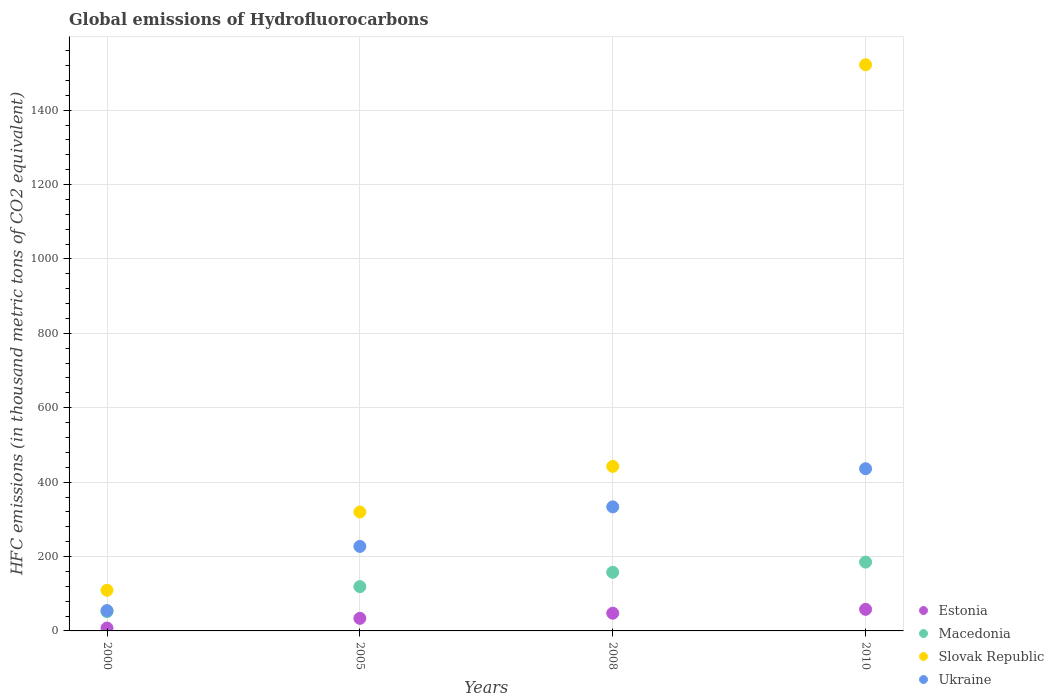What is the global emissions of Hydrofluorocarbons in Macedonia in 2010?
Offer a terse response. 185. Across all years, what is the maximum global emissions of Hydrofluorocarbons in Estonia?
Your response must be concise. 58. Across all years, what is the minimum global emissions of Hydrofluorocarbons in Slovak Republic?
Provide a short and direct response. 109.3. In which year was the global emissions of Hydrofluorocarbons in Ukraine maximum?
Ensure brevity in your answer.  2010. In which year was the global emissions of Hydrofluorocarbons in Slovak Republic minimum?
Provide a succinct answer. 2000. What is the total global emissions of Hydrofluorocarbons in Ukraine in the graph?
Your answer should be very brief. 1051.4. What is the difference between the global emissions of Hydrofluorocarbons in Macedonia in 2000 and that in 2010?
Your answer should be very brief. -133.2. What is the difference between the global emissions of Hydrofluorocarbons in Estonia in 2005 and the global emissions of Hydrofluorocarbons in Slovak Republic in 2010?
Keep it short and to the point. -1488.2. What is the average global emissions of Hydrofluorocarbons in Slovak Republic per year?
Your answer should be very brief. 598.33. In the year 2010, what is the difference between the global emissions of Hydrofluorocarbons in Estonia and global emissions of Hydrofluorocarbons in Slovak Republic?
Offer a terse response. -1464. What is the ratio of the global emissions of Hydrofluorocarbons in Ukraine in 2000 to that in 2005?
Give a very brief answer. 0.24. Is the difference between the global emissions of Hydrofluorocarbons in Estonia in 2000 and 2005 greater than the difference between the global emissions of Hydrofluorocarbons in Slovak Republic in 2000 and 2005?
Your answer should be compact. Yes. What is the difference between the highest and the second highest global emissions of Hydrofluorocarbons in Slovak Republic?
Give a very brief answer. 1079.7. What is the difference between the highest and the lowest global emissions of Hydrofluorocarbons in Macedonia?
Keep it short and to the point. 133.2. Is the sum of the global emissions of Hydrofluorocarbons in Macedonia in 2000 and 2008 greater than the maximum global emissions of Hydrofluorocarbons in Slovak Republic across all years?
Keep it short and to the point. No. Is it the case that in every year, the sum of the global emissions of Hydrofluorocarbons in Macedonia and global emissions of Hydrofluorocarbons in Estonia  is greater than the sum of global emissions of Hydrofluorocarbons in Slovak Republic and global emissions of Hydrofluorocarbons in Ukraine?
Ensure brevity in your answer.  No. Is it the case that in every year, the sum of the global emissions of Hydrofluorocarbons in Slovak Republic and global emissions of Hydrofluorocarbons in Macedonia  is greater than the global emissions of Hydrofluorocarbons in Estonia?
Provide a succinct answer. Yes. Is the global emissions of Hydrofluorocarbons in Slovak Republic strictly greater than the global emissions of Hydrofluorocarbons in Estonia over the years?
Provide a succinct answer. Yes. Is the global emissions of Hydrofluorocarbons in Slovak Republic strictly less than the global emissions of Hydrofluorocarbons in Estonia over the years?
Provide a succinct answer. No. How many years are there in the graph?
Keep it short and to the point. 4. Does the graph contain any zero values?
Your response must be concise. No. Does the graph contain grids?
Your answer should be compact. Yes. Where does the legend appear in the graph?
Make the answer very short. Bottom right. What is the title of the graph?
Provide a succinct answer. Global emissions of Hydrofluorocarbons. Does "Congo (Republic)" appear as one of the legend labels in the graph?
Provide a short and direct response. No. What is the label or title of the Y-axis?
Make the answer very short. HFC emissions (in thousand metric tons of CO2 equivalent). What is the HFC emissions (in thousand metric tons of CO2 equivalent) of Estonia in 2000?
Your answer should be very brief. 7.8. What is the HFC emissions (in thousand metric tons of CO2 equivalent) in Macedonia in 2000?
Offer a very short reply. 51.8. What is the HFC emissions (in thousand metric tons of CO2 equivalent) in Slovak Republic in 2000?
Your answer should be very brief. 109.3. What is the HFC emissions (in thousand metric tons of CO2 equivalent) of Ukraine in 2000?
Provide a short and direct response. 54.7. What is the HFC emissions (in thousand metric tons of CO2 equivalent) of Estonia in 2005?
Your response must be concise. 33.8. What is the HFC emissions (in thousand metric tons of CO2 equivalent) in Macedonia in 2005?
Offer a terse response. 119.1. What is the HFC emissions (in thousand metric tons of CO2 equivalent) in Slovak Republic in 2005?
Offer a terse response. 319.7. What is the HFC emissions (in thousand metric tons of CO2 equivalent) of Ukraine in 2005?
Your answer should be very brief. 227.2. What is the HFC emissions (in thousand metric tons of CO2 equivalent) in Estonia in 2008?
Your response must be concise. 47.6. What is the HFC emissions (in thousand metric tons of CO2 equivalent) in Macedonia in 2008?
Your response must be concise. 157.6. What is the HFC emissions (in thousand metric tons of CO2 equivalent) of Slovak Republic in 2008?
Offer a very short reply. 442.3. What is the HFC emissions (in thousand metric tons of CO2 equivalent) of Ukraine in 2008?
Offer a very short reply. 333.5. What is the HFC emissions (in thousand metric tons of CO2 equivalent) of Estonia in 2010?
Provide a succinct answer. 58. What is the HFC emissions (in thousand metric tons of CO2 equivalent) in Macedonia in 2010?
Offer a terse response. 185. What is the HFC emissions (in thousand metric tons of CO2 equivalent) of Slovak Republic in 2010?
Offer a terse response. 1522. What is the HFC emissions (in thousand metric tons of CO2 equivalent) of Ukraine in 2010?
Offer a terse response. 436. Across all years, what is the maximum HFC emissions (in thousand metric tons of CO2 equivalent) in Macedonia?
Make the answer very short. 185. Across all years, what is the maximum HFC emissions (in thousand metric tons of CO2 equivalent) in Slovak Republic?
Ensure brevity in your answer.  1522. Across all years, what is the maximum HFC emissions (in thousand metric tons of CO2 equivalent) in Ukraine?
Offer a very short reply. 436. Across all years, what is the minimum HFC emissions (in thousand metric tons of CO2 equivalent) of Estonia?
Keep it short and to the point. 7.8. Across all years, what is the minimum HFC emissions (in thousand metric tons of CO2 equivalent) of Macedonia?
Your response must be concise. 51.8. Across all years, what is the minimum HFC emissions (in thousand metric tons of CO2 equivalent) of Slovak Republic?
Offer a very short reply. 109.3. Across all years, what is the minimum HFC emissions (in thousand metric tons of CO2 equivalent) in Ukraine?
Ensure brevity in your answer.  54.7. What is the total HFC emissions (in thousand metric tons of CO2 equivalent) of Estonia in the graph?
Offer a very short reply. 147.2. What is the total HFC emissions (in thousand metric tons of CO2 equivalent) in Macedonia in the graph?
Ensure brevity in your answer.  513.5. What is the total HFC emissions (in thousand metric tons of CO2 equivalent) in Slovak Republic in the graph?
Offer a terse response. 2393.3. What is the total HFC emissions (in thousand metric tons of CO2 equivalent) of Ukraine in the graph?
Your response must be concise. 1051.4. What is the difference between the HFC emissions (in thousand metric tons of CO2 equivalent) in Macedonia in 2000 and that in 2005?
Provide a short and direct response. -67.3. What is the difference between the HFC emissions (in thousand metric tons of CO2 equivalent) of Slovak Republic in 2000 and that in 2005?
Provide a short and direct response. -210.4. What is the difference between the HFC emissions (in thousand metric tons of CO2 equivalent) in Ukraine in 2000 and that in 2005?
Keep it short and to the point. -172.5. What is the difference between the HFC emissions (in thousand metric tons of CO2 equivalent) in Estonia in 2000 and that in 2008?
Offer a very short reply. -39.8. What is the difference between the HFC emissions (in thousand metric tons of CO2 equivalent) in Macedonia in 2000 and that in 2008?
Your answer should be compact. -105.8. What is the difference between the HFC emissions (in thousand metric tons of CO2 equivalent) of Slovak Republic in 2000 and that in 2008?
Offer a terse response. -333. What is the difference between the HFC emissions (in thousand metric tons of CO2 equivalent) in Ukraine in 2000 and that in 2008?
Your response must be concise. -278.8. What is the difference between the HFC emissions (in thousand metric tons of CO2 equivalent) of Estonia in 2000 and that in 2010?
Make the answer very short. -50.2. What is the difference between the HFC emissions (in thousand metric tons of CO2 equivalent) of Macedonia in 2000 and that in 2010?
Your answer should be very brief. -133.2. What is the difference between the HFC emissions (in thousand metric tons of CO2 equivalent) in Slovak Republic in 2000 and that in 2010?
Offer a terse response. -1412.7. What is the difference between the HFC emissions (in thousand metric tons of CO2 equivalent) in Ukraine in 2000 and that in 2010?
Make the answer very short. -381.3. What is the difference between the HFC emissions (in thousand metric tons of CO2 equivalent) in Estonia in 2005 and that in 2008?
Your response must be concise. -13.8. What is the difference between the HFC emissions (in thousand metric tons of CO2 equivalent) in Macedonia in 2005 and that in 2008?
Offer a very short reply. -38.5. What is the difference between the HFC emissions (in thousand metric tons of CO2 equivalent) in Slovak Republic in 2005 and that in 2008?
Keep it short and to the point. -122.6. What is the difference between the HFC emissions (in thousand metric tons of CO2 equivalent) in Ukraine in 2005 and that in 2008?
Your answer should be compact. -106.3. What is the difference between the HFC emissions (in thousand metric tons of CO2 equivalent) of Estonia in 2005 and that in 2010?
Ensure brevity in your answer.  -24.2. What is the difference between the HFC emissions (in thousand metric tons of CO2 equivalent) of Macedonia in 2005 and that in 2010?
Your answer should be compact. -65.9. What is the difference between the HFC emissions (in thousand metric tons of CO2 equivalent) of Slovak Republic in 2005 and that in 2010?
Your answer should be very brief. -1202.3. What is the difference between the HFC emissions (in thousand metric tons of CO2 equivalent) of Ukraine in 2005 and that in 2010?
Provide a succinct answer. -208.8. What is the difference between the HFC emissions (in thousand metric tons of CO2 equivalent) in Estonia in 2008 and that in 2010?
Offer a terse response. -10.4. What is the difference between the HFC emissions (in thousand metric tons of CO2 equivalent) in Macedonia in 2008 and that in 2010?
Keep it short and to the point. -27.4. What is the difference between the HFC emissions (in thousand metric tons of CO2 equivalent) of Slovak Republic in 2008 and that in 2010?
Your answer should be compact. -1079.7. What is the difference between the HFC emissions (in thousand metric tons of CO2 equivalent) in Ukraine in 2008 and that in 2010?
Offer a terse response. -102.5. What is the difference between the HFC emissions (in thousand metric tons of CO2 equivalent) in Estonia in 2000 and the HFC emissions (in thousand metric tons of CO2 equivalent) in Macedonia in 2005?
Give a very brief answer. -111.3. What is the difference between the HFC emissions (in thousand metric tons of CO2 equivalent) of Estonia in 2000 and the HFC emissions (in thousand metric tons of CO2 equivalent) of Slovak Republic in 2005?
Offer a terse response. -311.9. What is the difference between the HFC emissions (in thousand metric tons of CO2 equivalent) of Estonia in 2000 and the HFC emissions (in thousand metric tons of CO2 equivalent) of Ukraine in 2005?
Your answer should be very brief. -219.4. What is the difference between the HFC emissions (in thousand metric tons of CO2 equivalent) in Macedonia in 2000 and the HFC emissions (in thousand metric tons of CO2 equivalent) in Slovak Republic in 2005?
Ensure brevity in your answer.  -267.9. What is the difference between the HFC emissions (in thousand metric tons of CO2 equivalent) of Macedonia in 2000 and the HFC emissions (in thousand metric tons of CO2 equivalent) of Ukraine in 2005?
Provide a short and direct response. -175.4. What is the difference between the HFC emissions (in thousand metric tons of CO2 equivalent) of Slovak Republic in 2000 and the HFC emissions (in thousand metric tons of CO2 equivalent) of Ukraine in 2005?
Your answer should be compact. -117.9. What is the difference between the HFC emissions (in thousand metric tons of CO2 equivalent) in Estonia in 2000 and the HFC emissions (in thousand metric tons of CO2 equivalent) in Macedonia in 2008?
Offer a very short reply. -149.8. What is the difference between the HFC emissions (in thousand metric tons of CO2 equivalent) of Estonia in 2000 and the HFC emissions (in thousand metric tons of CO2 equivalent) of Slovak Republic in 2008?
Provide a succinct answer. -434.5. What is the difference between the HFC emissions (in thousand metric tons of CO2 equivalent) of Estonia in 2000 and the HFC emissions (in thousand metric tons of CO2 equivalent) of Ukraine in 2008?
Keep it short and to the point. -325.7. What is the difference between the HFC emissions (in thousand metric tons of CO2 equivalent) in Macedonia in 2000 and the HFC emissions (in thousand metric tons of CO2 equivalent) in Slovak Republic in 2008?
Provide a succinct answer. -390.5. What is the difference between the HFC emissions (in thousand metric tons of CO2 equivalent) of Macedonia in 2000 and the HFC emissions (in thousand metric tons of CO2 equivalent) of Ukraine in 2008?
Give a very brief answer. -281.7. What is the difference between the HFC emissions (in thousand metric tons of CO2 equivalent) of Slovak Republic in 2000 and the HFC emissions (in thousand metric tons of CO2 equivalent) of Ukraine in 2008?
Provide a succinct answer. -224.2. What is the difference between the HFC emissions (in thousand metric tons of CO2 equivalent) in Estonia in 2000 and the HFC emissions (in thousand metric tons of CO2 equivalent) in Macedonia in 2010?
Your answer should be very brief. -177.2. What is the difference between the HFC emissions (in thousand metric tons of CO2 equivalent) of Estonia in 2000 and the HFC emissions (in thousand metric tons of CO2 equivalent) of Slovak Republic in 2010?
Your answer should be compact. -1514.2. What is the difference between the HFC emissions (in thousand metric tons of CO2 equivalent) of Estonia in 2000 and the HFC emissions (in thousand metric tons of CO2 equivalent) of Ukraine in 2010?
Your answer should be very brief. -428.2. What is the difference between the HFC emissions (in thousand metric tons of CO2 equivalent) in Macedonia in 2000 and the HFC emissions (in thousand metric tons of CO2 equivalent) in Slovak Republic in 2010?
Make the answer very short. -1470.2. What is the difference between the HFC emissions (in thousand metric tons of CO2 equivalent) of Macedonia in 2000 and the HFC emissions (in thousand metric tons of CO2 equivalent) of Ukraine in 2010?
Ensure brevity in your answer.  -384.2. What is the difference between the HFC emissions (in thousand metric tons of CO2 equivalent) of Slovak Republic in 2000 and the HFC emissions (in thousand metric tons of CO2 equivalent) of Ukraine in 2010?
Make the answer very short. -326.7. What is the difference between the HFC emissions (in thousand metric tons of CO2 equivalent) in Estonia in 2005 and the HFC emissions (in thousand metric tons of CO2 equivalent) in Macedonia in 2008?
Make the answer very short. -123.8. What is the difference between the HFC emissions (in thousand metric tons of CO2 equivalent) in Estonia in 2005 and the HFC emissions (in thousand metric tons of CO2 equivalent) in Slovak Republic in 2008?
Provide a short and direct response. -408.5. What is the difference between the HFC emissions (in thousand metric tons of CO2 equivalent) of Estonia in 2005 and the HFC emissions (in thousand metric tons of CO2 equivalent) of Ukraine in 2008?
Give a very brief answer. -299.7. What is the difference between the HFC emissions (in thousand metric tons of CO2 equivalent) of Macedonia in 2005 and the HFC emissions (in thousand metric tons of CO2 equivalent) of Slovak Republic in 2008?
Offer a very short reply. -323.2. What is the difference between the HFC emissions (in thousand metric tons of CO2 equivalent) in Macedonia in 2005 and the HFC emissions (in thousand metric tons of CO2 equivalent) in Ukraine in 2008?
Your answer should be very brief. -214.4. What is the difference between the HFC emissions (in thousand metric tons of CO2 equivalent) in Slovak Republic in 2005 and the HFC emissions (in thousand metric tons of CO2 equivalent) in Ukraine in 2008?
Ensure brevity in your answer.  -13.8. What is the difference between the HFC emissions (in thousand metric tons of CO2 equivalent) in Estonia in 2005 and the HFC emissions (in thousand metric tons of CO2 equivalent) in Macedonia in 2010?
Your response must be concise. -151.2. What is the difference between the HFC emissions (in thousand metric tons of CO2 equivalent) of Estonia in 2005 and the HFC emissions (in thousand metric tons of CO2 equivalent) of Slovak Republic in 2010?
Provide a short and direct response. -1488.2. What is the difference between the HFC emissions (in thousand metric tons of CO2 equivalent) of Estonia in 2005 and the HFC emissions (in thousand metric tons of CO2 equivalent) of Ukraine in 2010?
Make the answer very short. -402.2. What is the difference between the HFC emissions (in thousand metric tons of CO2 equivalent) of Macedonia in 2005 and the HFC emissions (in thousand metric tons of CO2 equivalent) of Slovak Republic in 2010?
Ensure brevity in your answer.  -1402.9. What is the difference between the HFC emissions (in thousand metric tons of CO2 equivalent) in Macedonia in 2005 and the HFC emissions (in thousand metric tons of CO2 equivalent) in Ukraine in 2010?
Your response must be concise. -316.9. What is the difference between the HFC emissions (in thousand metric tons of CO2 equivalent) of Slovak Republic in 2005 and the HFC emissions (in thousand metric tons of CO2 equivalent) of Ukraine in 2010?
Your response must be concise. -116.3. What is the difference between the HFC emissions (in thousand metric tons of CO2 equivalent) in Estonia in 2008 and the HFC emissions (in thousand metric tons of CO2 equivalent) in Macedonia in 2010?
Keep it short and to the point. -137.4. What is the difference between the HFC emissions (in thousand metric tons of CO2 equivalent) of Estonia in 2008 and the HFC emissions (in thousand metric tons of CO2 equivalent) of Slovak Republic in 2010?
Ensure brevity in your answer.  -1474.4. What is the difference between the HFC emissions (in thousand metric tons of CO2 equivalent) in Estonia in 2008 and the HFC emissions (in thousand metric tons of CO2 equivalent) in Ukraine in 2010?
Your answer should be very brief. -388.4. What is the difference between the HFC emissions (in thousand metric tons of CO2 equivalent) in Macedonia in 2008 and the HFC emissions (in thousand metric tons of CO2 equivalent) in Slovak Republic in 2010?
Ensure brevity in your answer.  -1364.4. What is the difference between the HFC emissions (in thousand metric tons of CO2 equivalent) in Macedonia in 2008 and the HFC emissions (in thousand metric tons of CO2 equivalent) in Ukraine in 2010?
Ensure brevity in your answer.  -278.4. What is the average HFC emissions (in thousand metric tons of CO2 equivalent) in Estonia per year?
Provide a short and direct response. 36.8. What is the average HFC emissions (in thousand metric tons of CO2 equivalent) in Macedonia per year?
Offer a terse response. 128.38. What is the average HFC emissions (in thousand metric tons of CO2 equivalent) of Slovak Republic per year?
Offer a very short reply. 598.33. What is the average HFC emissions (in thousand metric tons of CO2 equivalent) in Ukraine per year?
Give a very brief answer. 262.85. In the year 2000, what is the difference between the HFC emissions (in thousand metric tons of CO2 equivalent) of Estonia and HFC emissions (in thousand metric tons of CO2 equivalent) of Macedonia?
Make the answer very short. -44. In the year 2000, what is the difference between the HFC emissions (in thousand metric tons of CO2 equivalent) in Estonia and HFC emissions (in thousand metric tons of CO2 equivalent) in Slovak Republic?
Your answer should be compact. -101.5. In the year 2000, what is the difference between the HFC emissions (in thousand metric tons of CO2 equivalent) of Estonia and HFC emissions (in thousand metric tons of CO2 equivalent) of Ukraine?
Ensure brevity in your answer.  -46.9. In the year 2000, what is the difference between the HFC emissions (in thousand metric tons of CO2 equivalent) of Macedonia and HFC emissions (in thousand metric tons of CO2 equivalent) of Slovak Republic?
Your response must be concise. -57.5. In the year 2000, what is the difference between the HFC emissions (in thousand metric tons of CO2 equivalent) of Slovak Republic and HFC emissions (in thousand metric tons of CO2 equivalent) of Ukraine?
Provide a succinct answer. 54.6. In the year 2005, what is the difference between the HFC emissions (in thousand metric tons of CO2 equivalent) in Estonia and HFC emissions (in thousand metric tons of CO2 equivalent) in Macedonia?
Your answer should be very brief. -85.3. In the year 2005, what is the difference between the HFC emissions (in thousand metric tons of CO2 equivalent) in Estonia and HFC emissions (in thousand metric tons of CO2 equivalent) in Slovak Republic?
Ensure brevity in your answer.  -285.9. In the year 2005, what is the difference between the HFC emissions (in thousand metric tons of CO2 equivalent) of Estonia and HFC emissions (in thousand metric tons of CO2 equivalent) of Ukraine?
Ensure brevity in your answer.  -193.4. In the year 2005, what is the difference between the HFC emissions (in thousand metric tons of CO2 equivalent) of Macedonia and HFC emissions (in thousand metric tons of CO2 equivalent) of Slovak Republic?
Give a very brief answer. -200.6. In the year 2005, what is the difference between the HFC emissions (in thousand metric tons of CO2 equivalent) in Macedonia and HFC emissions (in thousand metric tons of CO2 equivalent) in Ukraine?
Offer a very short reply. -108.1. In the year 2005, what is the difference between the HFC emissions (in thousand metric tons of CO2 equivalent) of Slovak Republic and HFC emissions (in thousand metric tons of CO2 equivalent) of Ukraine?
Your answer should be very brief. 92.5. In the year 2008, what is the difference between the HFC emissions (in thousand metric tons of CO2 equivalent) in Estonia and HFC emissions (in thousand metric tons of CO2 equivalent) in Macedonia?
Ensure brevity in your answer.  -110. In the year 2008, what is the difference between the HFC emissions (in thousand metric tons of CO2 equivalent) in Estonia and HFC emissions (in thousand metric tons of CO2 equivalent) in Slovak Republic?
Keep it short and to the point. -394.7. In the year 2008, what is the difference between the HFC emissions (in thousand metric tons of CO2 equivalent) in Estonia and HFC emissions (in thousand metric tons of CO2 equivalent) in Ukraine?
Offer a terse response. -285.9. In the year 2008, what is the difference between the HFC emissions (in thousand metric tons of CO2 equivalent) in Macedonia and HFC emissions (in thousand metric tons of CO2 equivalent) in Slovak Republic?
Give a very brief answer. -284.7. In the year 2008, what is the difference between the HFC emissions (in thousand metric tons of CO2 equivalent) of Macedonia and HFC emissions (in thousand metric tons of CO2 equivalent) of Ukraine?
Provide a short and direct response. -175.9. In the year 2008, what is the difference between the HFC emissions (in thousand metric tons of CO2 equivalent) in Slovak Republic and HFC emissions (in thousand metric tons of CO2 equivalent) in Ukraine?
Your response must be concise. 108.8. In the year 2010, what is the difference between the HFC emissions (in thousand metric tons of CO2 equivalent) in Estonia and HFC emissions (in thousand metric tons of CO2 equivalent) in Macedonia?
Your answer should be compact. -127. In the year 2010, what is the difference between the HFC emissions (in thousand metric tons of CO2 equivalent) in Estonia and HFC emissions (in thousand metric tons of CO2 equivalent) in Slovak Republic?
Your answer should be compact. -1464. In the year 2010, what is the difference between the HFC emissions (in thousand metric tons of CO2 equivalent) in Estonia and HFC emissions (in thousand metric tons of CO2 equivalent) in Ukraine?
Ensure brevity in your answer.  -378. In the year 2010, what is the difference between the HFC emissions (in thousand metric tons of CO2 equivalent) of Macedonia and HFC emissions (in thousand metric tons of CO2 equivalent) of Slovak Republic?
Offer a terse response. -1337. In the year 2010, what is the difference between the HFC emissions (in thousand metric tons of CO2 equivalent) in Macedonia and HFC emissions (in thousand metric tons of CO2 equivalent) in Ukraine?
Give a very brief answer. -251. In the year 2010, what is the difference between the HFC emissions (in thousand metric tons of CO2 equivalent) of Slovak Republic and HFC emissions (in thousand metric tons of CO2 equivalent) of Ukraine?
Keep it short and to the point. 1086. What is the ratio of the HFC emissions (in thousand metric tons of CO2 equivalent) of Estonia in 2000 to that in 2005?
Provide a succinct answer. 0.23. What is the ratio of the HFC emissions (in thousand metric tons of CO2 equivalent) in Macedonia in 2000 to that in 2005?
Provide a succinct answer. 0.43. What is the ratio of the HFC emissions (in thousand metric tons of CO2 equivalent) of Slovak Republic in 2000 to that in 2005?
Your answer should be compact. 0.34. What is the ratio of the HFC emissions (in thousand metric tons of CO2 equivalent) of Ukraine in 2000 to that in 2005?
Your answer should be very brief. 0.24. What is the ratio of the HFC emissions (in thousand metric tons of CO2 equivalent) of Estonia in 2000 to that in 2008?
Provide a succinct answer. 0.16. What is the ratio of the HFC emissions (in thousand metric tons of CO2 equivalent) in Macedonia in 2000 to that in 2008?
Provide a succinct answer. 0.33. What is the ratio of the HFC emissions (in thousand metric tons of CO2 equivalent) in Slovak Republic in 2000 to that in 2008?
Provide a short and direct response. 0.25. What is the ratio of the HFC emissions (in thousand metric tons of CO2 equivalent) in Ukraine in 2000 to that in 2008?
Give a very brief answer. 0.16. What is the ratio of the HFC emissions (in thousand metric tons of CO2 equivalent) of Estonia in 2000 to that in 2010?
Offer a terse response. 0.13. What is the ratio of the HFC emissions (in thousand metric tons of CO2 equivalent) of Macedonia in 2000 to that in 2010?
Provide a short and direct response. 0.28. What is the ratio of the HFC emissions (in thousand metric tons of CO2 equivalent) of Slovak Republic in 2000 to that in 2010?
Ensure brevity in your answer.  0.07. What is the ratio of the HFC emissions (in thousand metric tons of CO2 equivalent) in Ukraine in 2000 to that in 2010?
Make the answer very short. 0.13. What is the ratio of the HFC emissions (in thousand metric tons of CO2 equivalent) of Estonia in 2005 to that in 2008?
Offer a very short reply. 0.71. What is the ratio of the HFC emissions (in thousand metric tons of CO2 equivalent) in Macedonia in 2005 to that in 2008?
Make the answer very short. 0.76. What is the ratio of the HFC emissions (in thousand metric tons of CO2 equivalent) in Slovak Republic in 2005 to that in 2008?
Offer a terse response. 0.72. What is the ratio of the HFC emissions (in thousand metric tons of CO2 equivalent) in Ukraine in 2005 to that in 2008?
Give a very brief answer. 0.68. What is the ratio of the HFC emissions (in thousand metric tons of CO2 equivalent) in Estonia in 2005 to that in 2010?
Provide a succinct answer. 0.58. What is the ratio of the HFC emissions (in thousand metric tons of CO2 equivalent) of Macedonia in 2005 to that in 2010?
Provide a short and direct response. 0.64. What is the ratio of the HFC emissions (in thousand metric tons of CO2 equivalent) in Slovak Republic in 2005 to that in 2010?
Make the answer very short. 0.21. What is the ratio of the HFC emissions (in thousand metric tons of CO2 equivalent) in Ukraine in 2005 to that in 2010?
Provide a short and direct response. 0.52. What is the ratio of the HFC emissions (in thousand metric tons of CO2 equivalent) of Estonia in 2008 to that in 2010?
Provide a short and direct response. 0.82. What is the ratio of the HFC emissions (in thousand metric tons of CO2 equivalent) of Macedonia in 2008 to that in 2010?
Offer a very short reply. 0.85. What is the ratio of the HFC emissions (in thousand metric tons of CO2 equivalent) in Slovak Republic in 2008 to that in 2010?
Your answer should be very brief. 0.29. What is the ratio of the HFC emissions (in thousand metric tons of CO2 equivalent) in Ukraine in 2008 to that in 2010?
Ensure brevity in your answer.  0.76. What is the difference between the highest and the second highest HFC emissions (in thousand metric tons of CO2 equivalent) of Macedonia?
Offer a terse response. 27.4. What is the difference between the highest and the second highest HFC emissions (in thousand metric tons of CO2 equivalent) in Slovak Republic?
Make the answer very short. 1079.7. What is the difference between the highest and the second highest HFC emissions (in thousand metric tons of CO2 equivalent) of Ukraine?
Your response must be concise. 102.5. What is the difference between the highest and the lowest HFC emissions (in thousand metric tons of CO2 equivalent) of Estonia?
Your answer should be compact. 50.2. What is the difference between the highest and the lowest HFC emissions (in thousand metric tons of CO2 equivalent) of Macedonia?
Offer a terse response. 133.2. What is the difference between the highest and the lowest HFC emissions (in thousand metric tons of CO2 equivalent) in Slovak Republic?
Provide a short and direct response. 1412.7. What is the difference between the highest and the lowest HFC emissions (in thousand metric tons of CO2 equivalent) of Ukraine?
Your response must be concise. 381.3. 